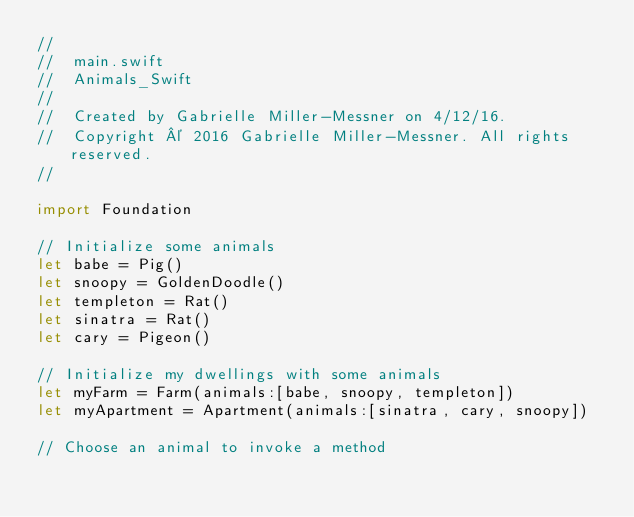Convert code to text. <code><loc_0><loc_0><loc_500><loc_500><_Swift_>//
//  main.swift
//  Animals_Swift
//
//  Created by Gabrielle Miller-Messner on 4/12/16.
//  Copyright © 2016 Gabrielle Miller-Messner. All rights reserved.
//

import Foundation

// Initialize some animals
let babe = Pig()
let snoopy = GoldenDoodle()
let templeton = Rat()
let sinatra = Rat()
let cary = Pigeon()

// Initialize my dwellings with some animals
let myFarm = Farm(animals:[babe, snoopy, templeton])
let myApartment = Apartment(animals:[sinatra, cary, snoopy])

// Choose an animal to invoke a method</code> 